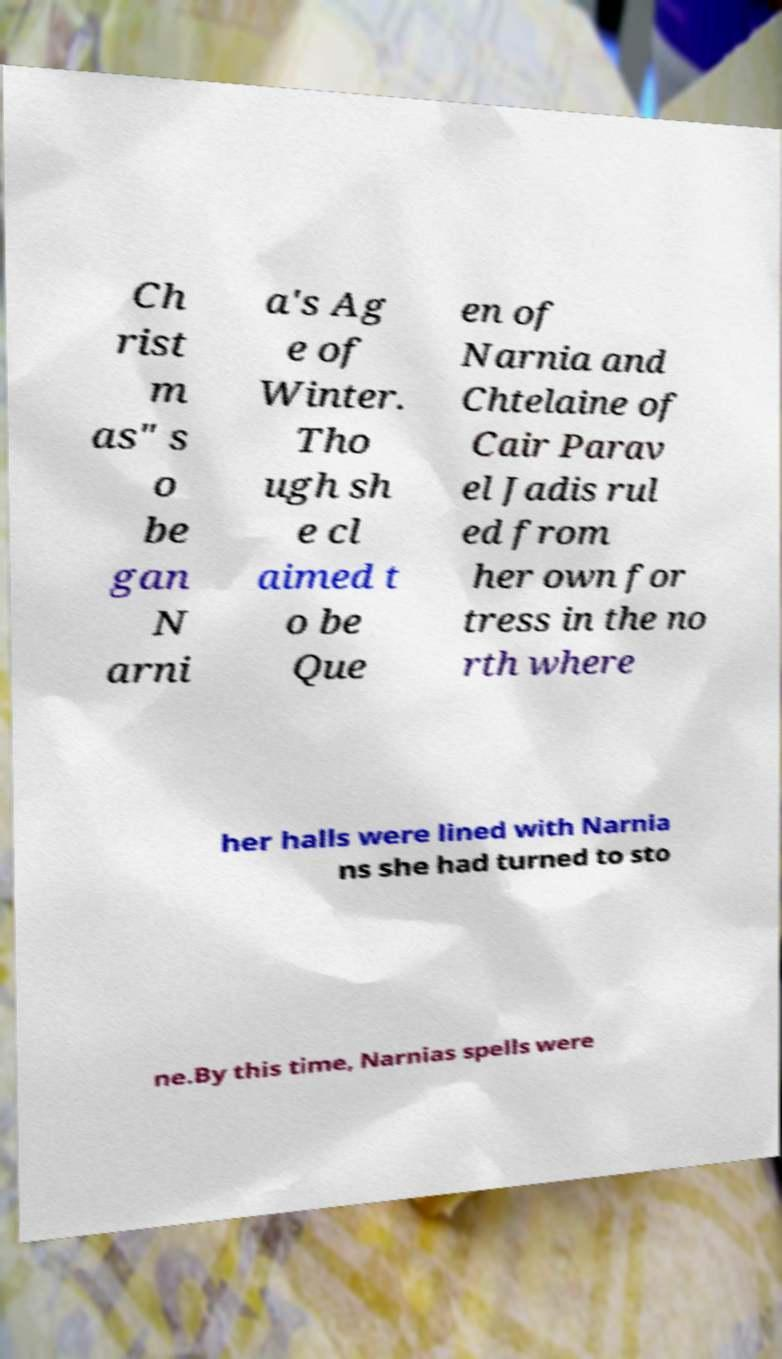I need the written content from this picture converted into text. Can you do that? Ch rist m as" s o be gan N arni a's Ag e of Winter. Tho ugh sh e cl aimed t o be Que en of Narnia and Chtelaine of Cair Parav el Jadis rul ed from her own for tress in the no rth where her halls were lined with Narnia ns she had turned to sto ne.By this time, Narnias spells were 